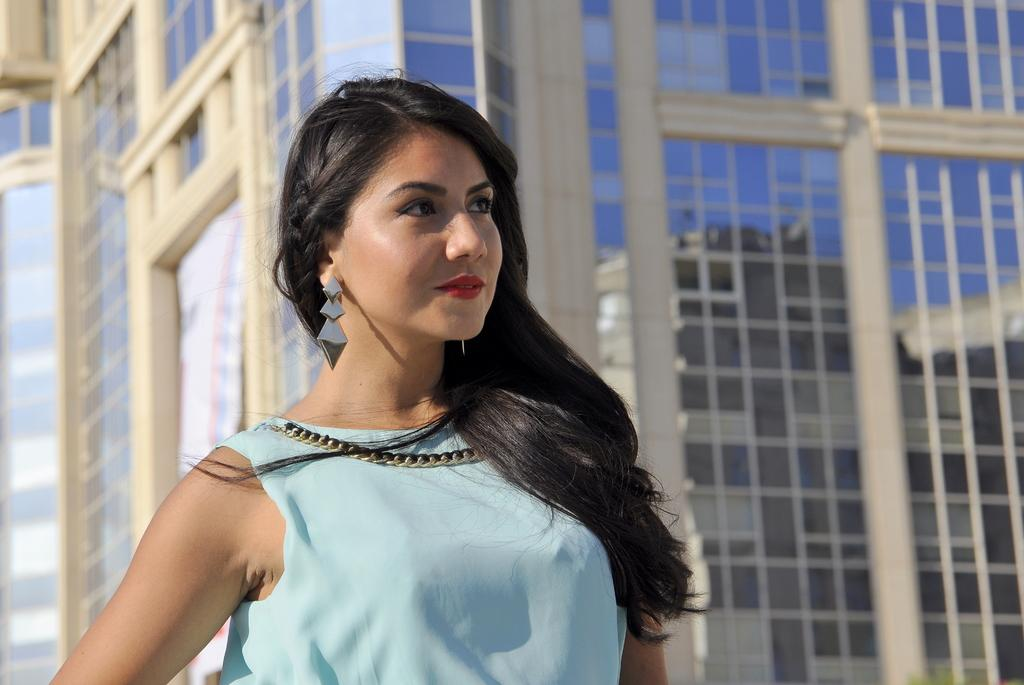Who is present in the image? There is a woman in the image. What can be seen in the background of the image? There is a building in the background of the image. What type of glove is the woman wearing in the image? There is no glove visible in the image. How does the woman interact with the waves in the image? There are no waves present in the image, so the woman cannot interact with them. 